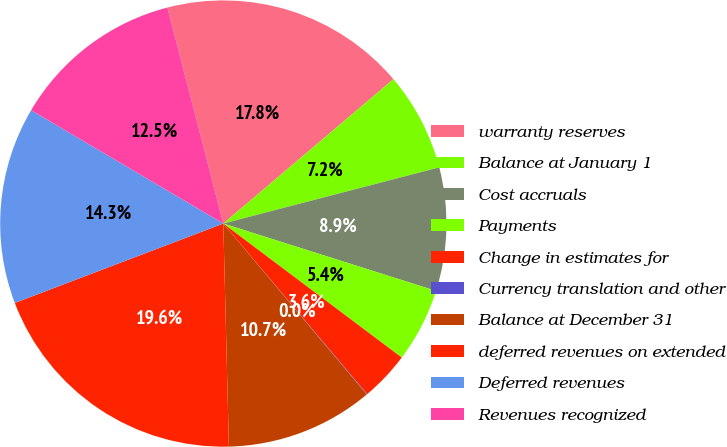<chart> <loc_0><loc_0><loc_500><loc_500><pie_chart><fcel>warranty reserves<fcel>Balance at January 1<fcel>Cost accruals<fcel>Payments<fcel>Change in estimates for<fcel>Currency translation and other<fcel>Balance at December 31<fcel>deferred revenues on extended<fcel>Deferred revenues<fcel>Revenues recognized<nl><fcel>17.83%<fcel>7.15%<fcel>8.93%<fcel>5.37%<fcel>3.6%<fcel>0.04%<fcel>10.71%<fcel>19.61%<fcel>14.27%<fcel>12.49%<nl></chart> 